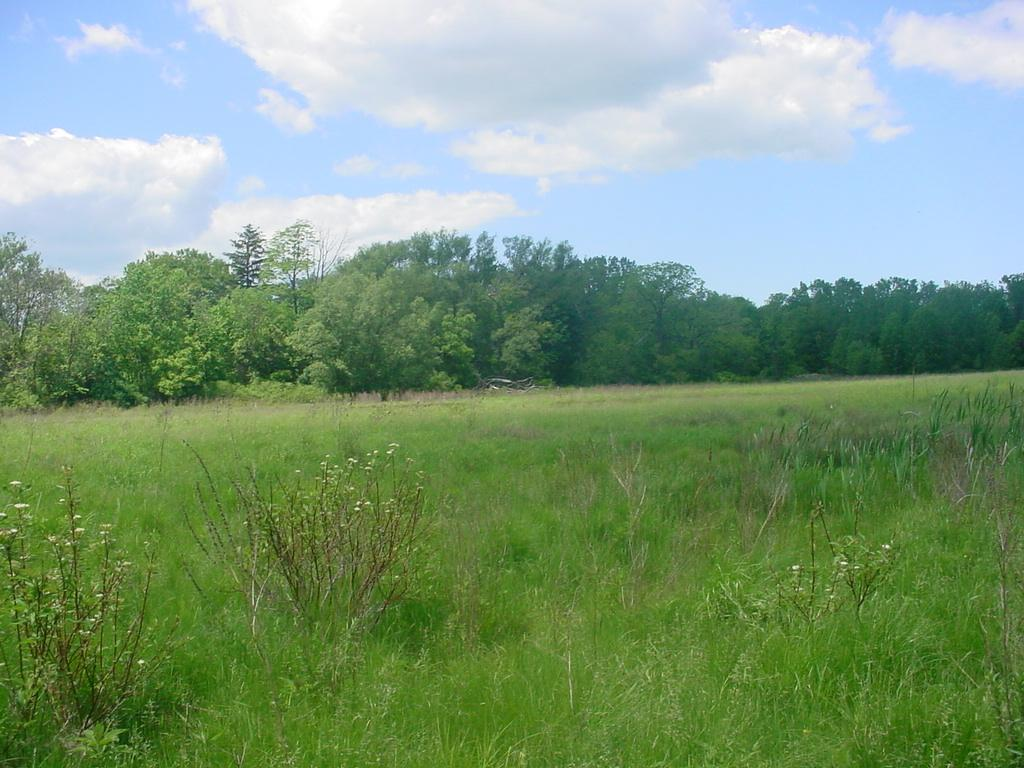What types of plants are in the foreground of the image? There is a group of plants in the foreground of the image. What else can be seen in the foreground of the image? There is grass in the foreground of the image. What is visible in the background of the image? There is a group of trees in the background of the image, and the sky is visible. How would you describe the sky in the image? The sky appears to be cloudy in the image. Are there any cherries hanging from the trees in the image? There is no mention of cherries in the provided facts, so we cannot determine if they are present in the image. 